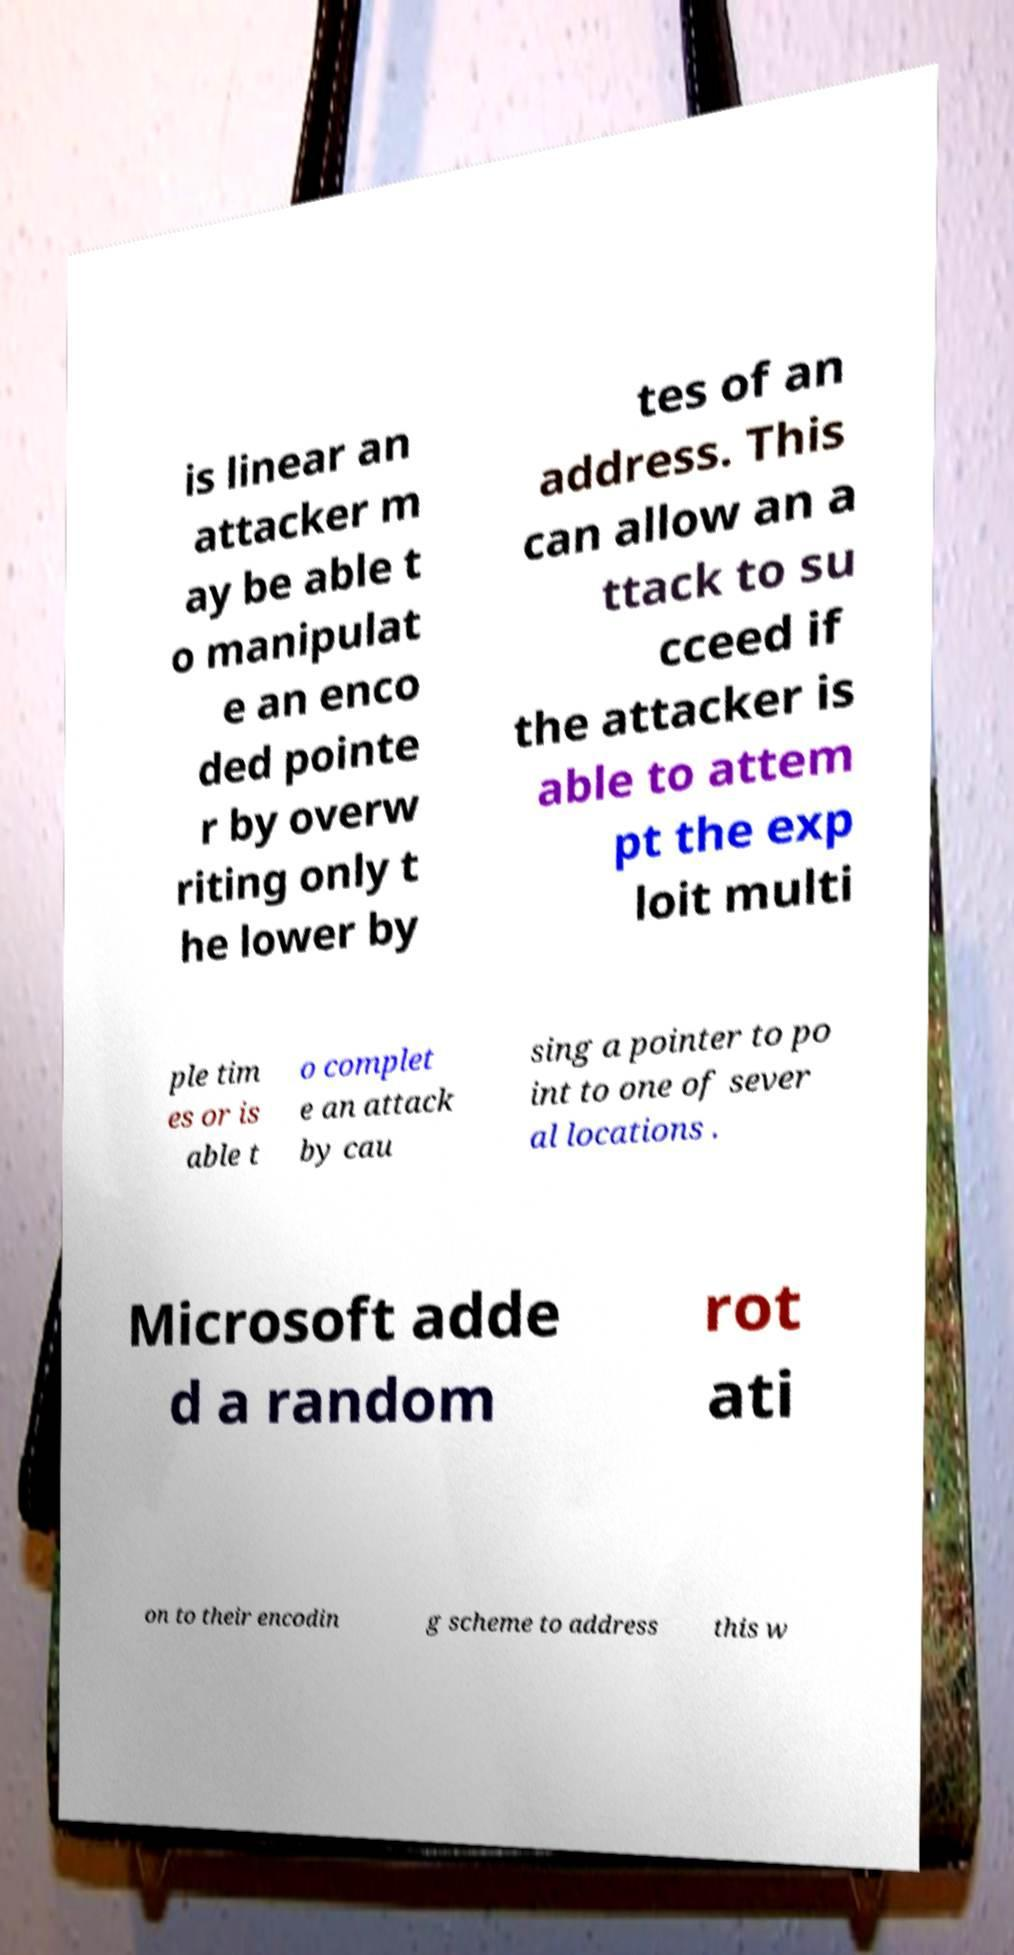Can you accurately transcribe the text from the provided image for me? is linear an attacker m ay be able t o manipulat e an enco ded pointe r by overw riting only t he lower by tes of an address. This can allow an a ttack to su cceed if the attacker is able to attem pt the exp loit multi ple tim es or is able t o complet e an attack by cau sing a pointer to po int to one of sever al locations . Microsoft adde d a random rot ati on to their encodin g scheme to address this w 